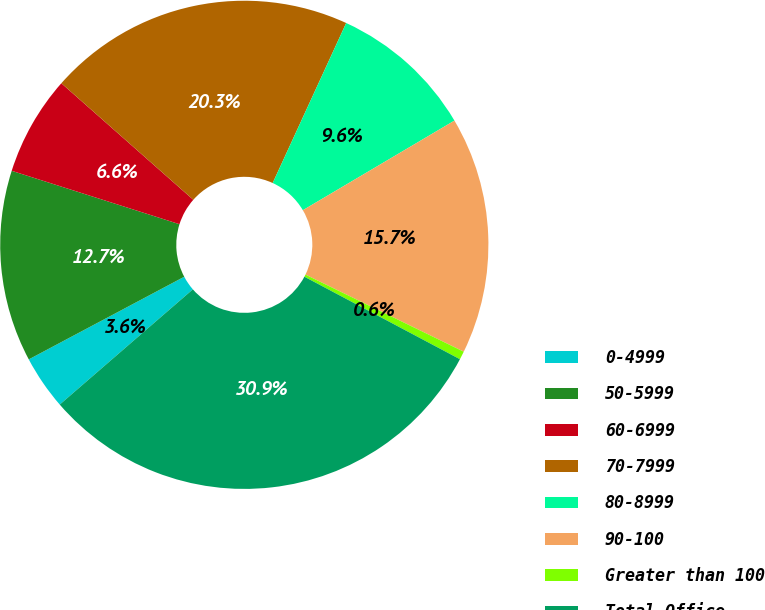Convert chart to OTSL. <chart><loc_0><loc_0><loc_500><loc_500><pie_chart><fcel>0-4999<fcel>50-5999<fcel>60-6999<fcel>70-7999<fcel>80-8999<fcel>90-100<fcel>Greater than 100<fcel>Total Office<nl><fcel>3.58%<fcel>12.68%<fcel>6.61%<fcel>20.34%<fcel>9.65%<fcel>15.71%<fcel>0.55%<fcel>30.88%<nl></chart> 